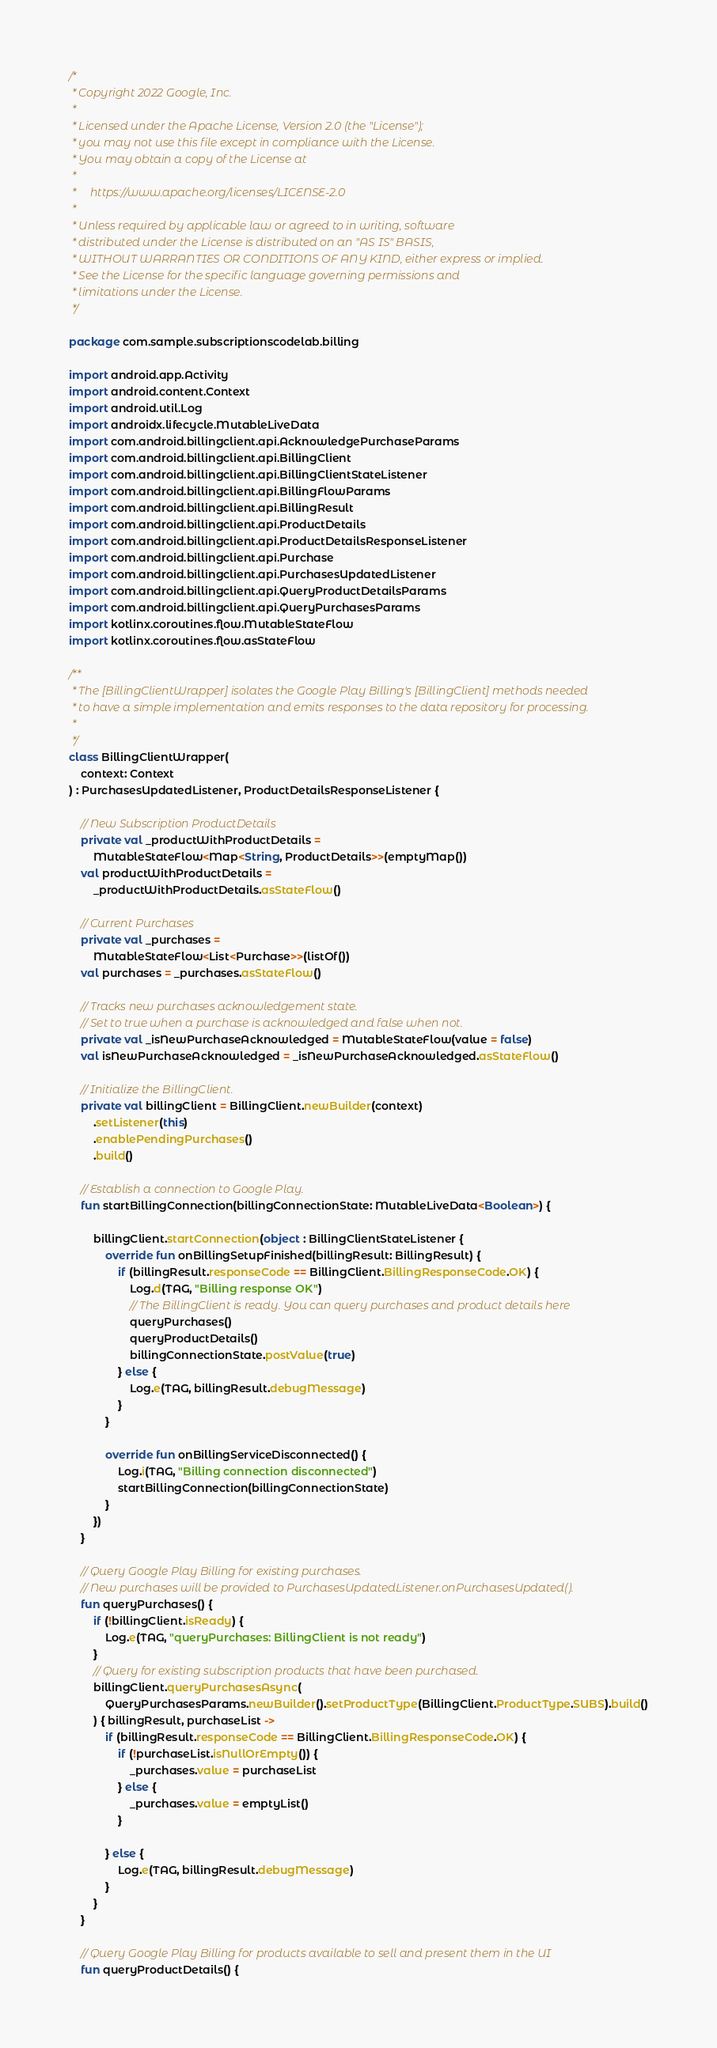Convert code to text. <code><loc_0><loc_0><loc_500><loc_500><_Kotlin_>/*
 * Copyright 2022 Google, Inc.
 *
 * Licensed under the Apache License, Version 2.0 (the "License");
 * you may not use this file except in compliance with the License.
 * You may obtain a copy of the License at
 *
 *     https://www.apache.org/licenses/LICENSE-2.0
 *
 * Unless required by applicable law or agreed to in writing, software
 * distributed under the License is distributed on an "AS IS" BASIS,
 * WITHOUT WARRANTIES OR CONDITIONS OF ANY KIND, either express or implied.
 * See the License for the specific language governing permissions and
 * limitations under the License.
 */

package com.sample.subscriptionscodelab.billing

import android.app.Activity
import android.content.Context
import android.util.Log
import androidx.lifecycle.MutableLiveData
import com.android.billingclient.api.AcknowledgePurchaseParams
import com.android.billingclient.api.BillingClient
import com.android.billingclient.api.BillingClientStateListener
import com.android.billingclient.api.BillingFlowParams
import com.android.billingclient.api.BillingResult
import com.android.billingclient.api.ProductDetails
import com.android.billingclient.api.ProductDetailsResponseListener
import com.android.billingclient.api.Purchase
import com.android.billingclient.api.PurchasesUpdatedListener
import com.android.billingclient.api.QueryProductDetailsParams
import com.android.billingclient.api.QueryPurchasesParams
import kotlinx.coroutines.flow.MutableStateFlow
import kotlinx.coroutines.flow.asStateFlow

/**
 * The [BillingClientWrapper] isolates the Google Play Billing's [BillingClient] methods needed
 * to have a simple implementation and emits responses to the data repository for processing.
 *
 */
class BillingClientWrapper(
    context: Context
) : PurchasesUpdatedListener, ProductDetailsResponseListener {

    // New Subscription ProductDetails
    private val _productWithProductDetails =
        MutableStateFlow<Map<String, ProductDetails>>(emptyMap())
    val productWithProductDetails =
        _productWithProductDetails.asStateFlow()

    // Current Purchases
    private val _purchases =
        MutableStateFlow<List<Purchase>>(listOf())
    val purchases = _purchases.asStateFlow()

    // Tracks new purchases acknowledgement state.
    // Set to true when a purchase is acknowledged and false when not.
    private val _isNewPurchaseAcknowledged = MutableStateFlow(value = false)
    val isNewPurchaseAcknowledged = _isNewPurchaseAcknowledged.asStateFlow()

    // Initialize the BillingClient.
    private val billingClient = BillingClient.newBuilder(context)
        .setListener(this)
        .enablePendingPurchases()
        .build()

    // Establish a connection to Google Play.
    fun startBillingConnection(billingConnectionState: MutableLiveData<Boolean>) {

        billingClient.startConnection(object : BillingClientStateListener {
            override fun onBillingSetupFinished(billingResult: BillingResult) {
                if (billingResult.responseCode == BillingClient.BillingResponseCode.OK) {
                    Log.d(TAG, "Billing response OK")
                    // The BillingClient is ready. You can query purchases and product details here
                    queryPurchases()
                    queryProductDetails()
                    billingConnectionState.postValue(true)
                } else {
                    Log.e(TAG, billingResult.debugMessage)
                }
            }

            override fun onBillingServiceDisconnected() {
                Log.i(TAG, "Billing connection disconnected")
                startBillingConnection(billingConnectionState)
            }
        })
    }

    // Query Google Play Billing for existing purchases.
    // New purchases will be provided to PurchasesUpdatedListener.onPurchasesUpdated().
    fun queryPurchases() {
        if (!billingClient.isReady) {
            Log.e(TAG, "queryPurchases: BillingClient is not ready")
        }
        // Query for existing subscription products that have been purchased.
        billingClient.queryPurchasesAsync(
            QueryPurchasesParams.newBuilder().setProductType(BillingClient.ProductType.SUBS).build()
        ) { billingResult, purchaseList ->
            if (billingResult.responseCode == BillingClient.BillingResponseCode.OK) {
                if (!purchaseList.isNullOrEmpty()) {
                    _purchases.value = purchaseList
                } else {
                    _purchases.value = emptyList()
                }

            } else {
                Log.e(TAG, billingResult.debugMessage)
            }
        }
    }

    // Query Google Play Billing for products available to sell and present them in the UI
    fun queryProductDetails() {</code> 